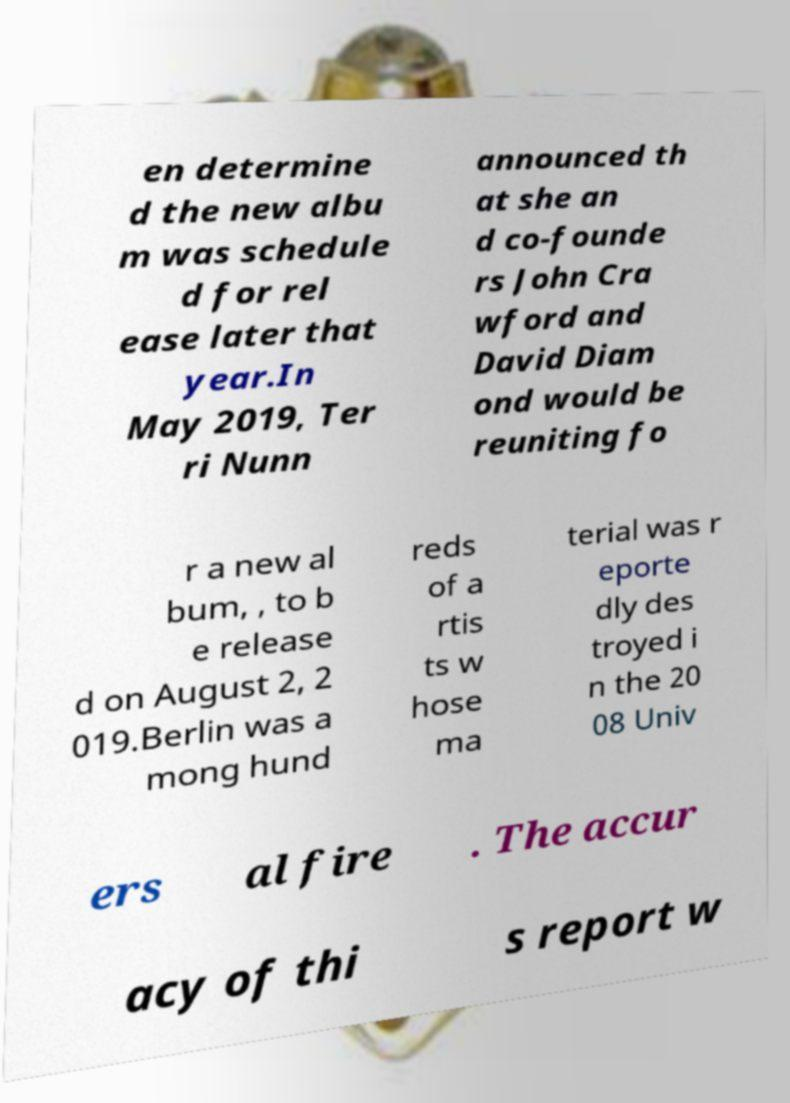Please identify and transcribe the text found in this image. en determine d the new albu m was schedule d for rel ease later that year.In May 2019, Ter ri Nunn announced th at she an d co-founde rs John Cra wford and David Diam ond would be reuniting fo r a new al bum, , to b e release d on August 2, 2 019.Berlin was a mong hund reds of a rtis ts w hose ma terial was r eporte dly des troyed i n the 20 08 Univ ers al fire . The accur acy of thi s report w 